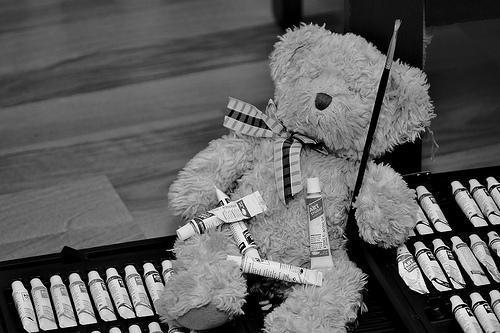How many teddy bears are there?
Give a very brief answer. 1. 